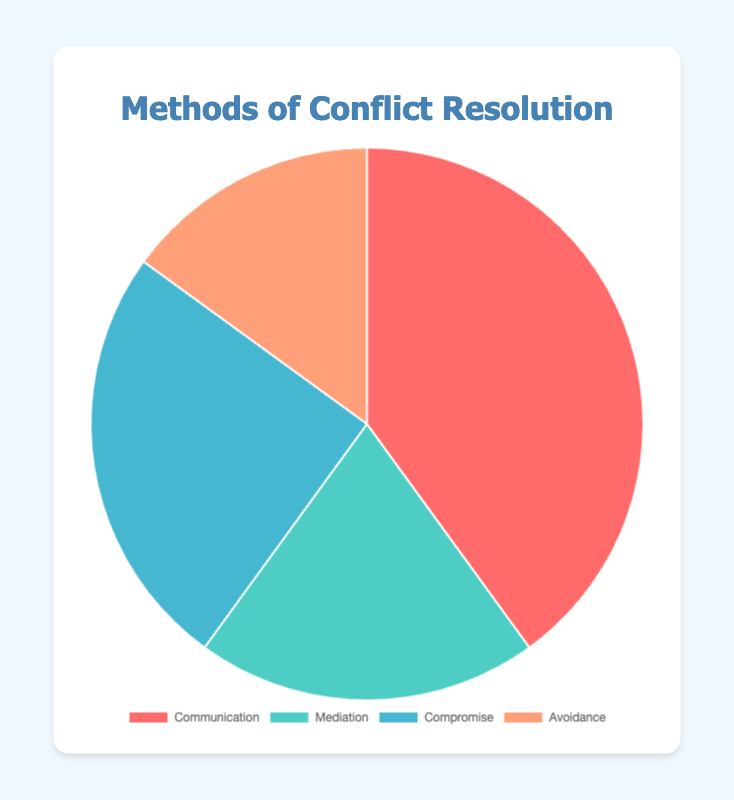What is the most commonly used method of conflict resolution? The pie chart shows that the "Communication" slice is the largest, representing 40%.
Answer: Communication Which method is used less frequently, Mediation or Compromise? The pie chart indicates the percentages for Mediation and Compromise are 20% and 25%, respectively. Therefore, Mediation is used less frequently.
Answer: Mediation What percentage of methods involves direct interaction (Communication and Mediation combined)? Add the percentages for Communication (40%) and Mediation (20%): 40% + 20% = 60%.
Answer: 60% Which method has the smallest visual representation in the pie chart? The pie chart shows the smallest slice is labeled as "Avoidance," which corresponds to 15%.
Answer: Avoidance How much more frequently is Compromise used compared to Avoidance? Subtract the percentage for Avoidance (15%) from the percentage for Compromise (25%): 25% - 15% = 10%.
Answer: 10% If you combine the percentages of the two least common methods, what percentage do you get? Add the percentages for Mediation (20%) and Avoidance (15%): 20% + 15% = 35%.
Answer: 35% What are the colors associated with Communication and Mediation in the chart? The pie chart uses distinct colors for each method: Communication is represented in red and Mediation in green.
Answer: Red and Green What is the difference in percentage between the most and least used methods of conflict resolution? Subtract the percentage of the least used method (Avoidance, 15%) from the most used method (Communication, 40%): 40% - 15% = 25%.
Answer: 25% What fraction of the methods of conflict resolution does Avoidance represent in comparison to the whole? Avoidance is 15% of the whole, which can be represented as 15/100 or simplified to 3/20.
Answer: 3/20 